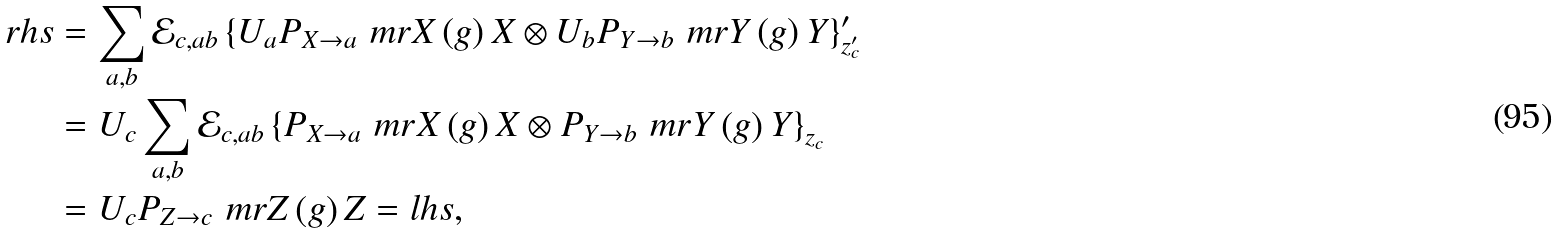<formula> <loc_0><loc_0><loc_500><loc_500>r h s & = \sum _ { a , b } \mathcal { E } _ { c , a b } \left \{ U _ { a } P _ { X \to a } \ m r { X } \left ( g \right ) X \otimes U _ { b } P _ { Y \to b } \ m r { Y } \left ( g \right ) Y \right \} _ { z _ { c } ^ { \prime } } ^ { \prime } \\ & = U _ { c } \sum _ { a , b } \mathcal { E } _ { c , a b } \left \{ P _ { X \to a } \ m r { X } \left ( g \right ) X \otimes P _ { Y \to b } \ m r { Y } \left ( g \right ) Y \right \} _ { z _ { c } } \\ & = U _ { c } P _ { Z \to c } \ m r { Z } \left ( g \right ) Z = l h s ,</formula> 